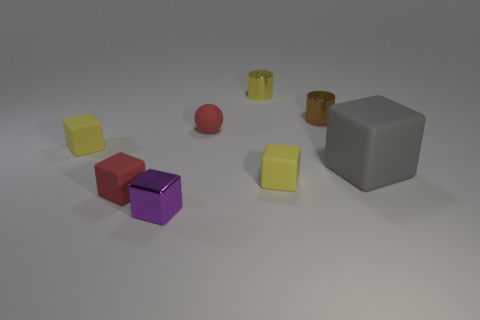Are there any big blue spheres that have the same material as the red sphere? no 